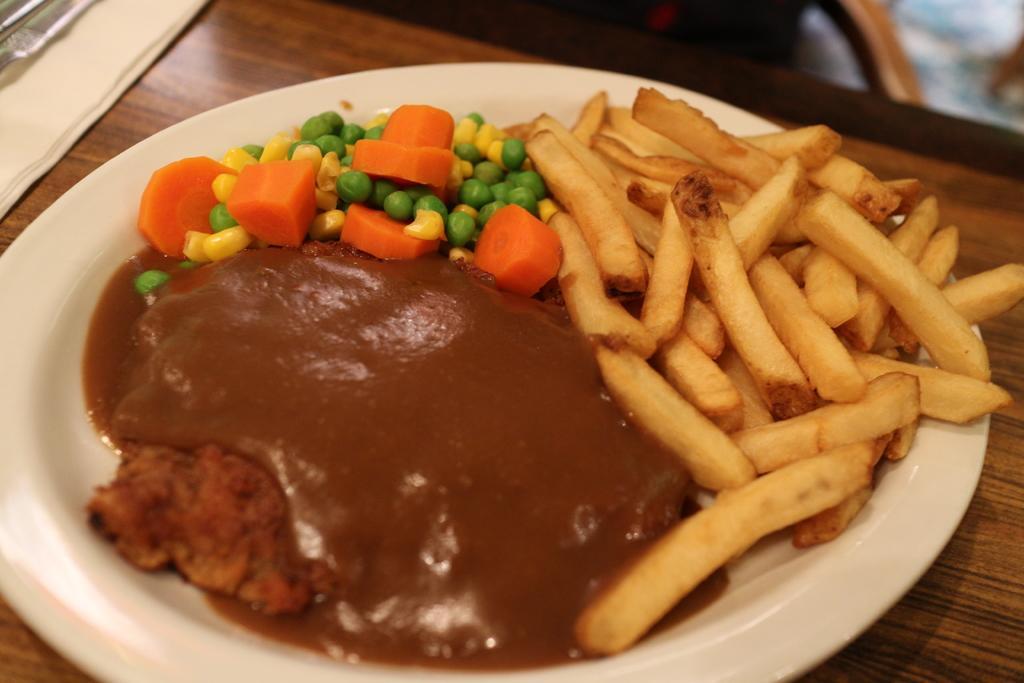How would you summarize this image in a sentence or two? In the image we can see wooden surface and on it there is a plate, white in color. In the plate we can see fence fries, slices of carrot, corn grains and pees and chutney. 